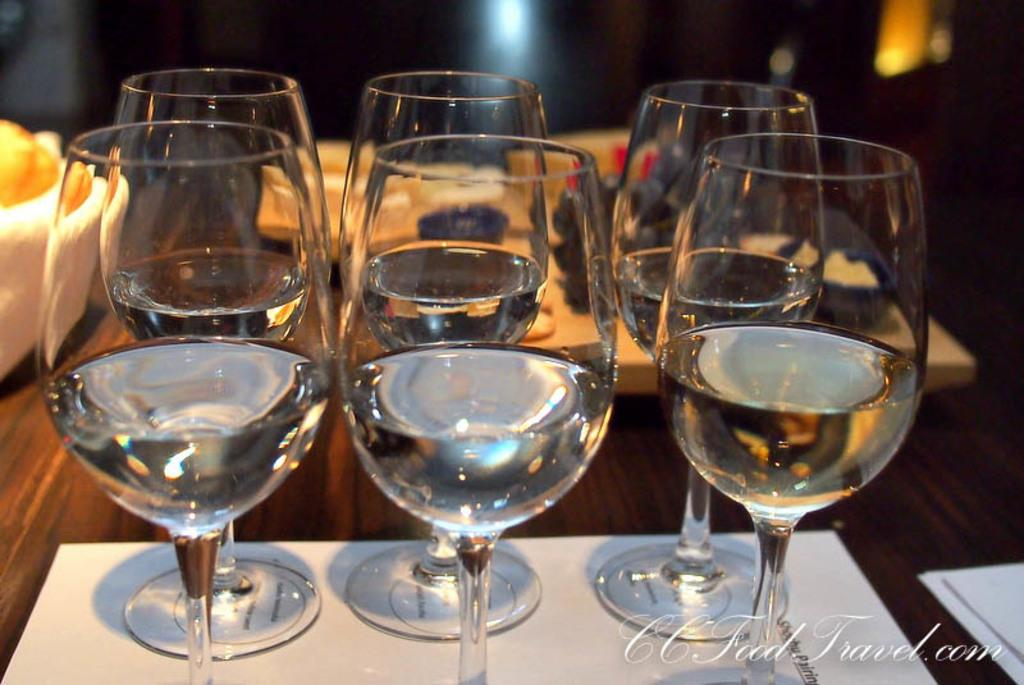What objects are placed on a paper in the image? There are glasses on a paper in the image. Where is the bowl located in the image? The bowl is on the left side of the image. What can be seen on the right side of the image? There are papers on the right side of the image. What can be seen in the background of the image? There are lights visible in the background of the image. How many children are playing with sticks in the image? There are no children or sticks present in the image. Is there a visitor in the image? There is no mention of a visitor in the provided facts, and therefore we cannot determine if there is a visitor in the image. 